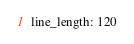Convert code to text. <code><loc_0><loc_0><loc_500><loc_500><_YAML_>line_length: 120
</code> 